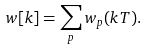<formula> <loc_0><loc_0><loc_500><loc_500>w [ k ] = \sum _ { p } w _ { p } ( k T ) .</formula> 